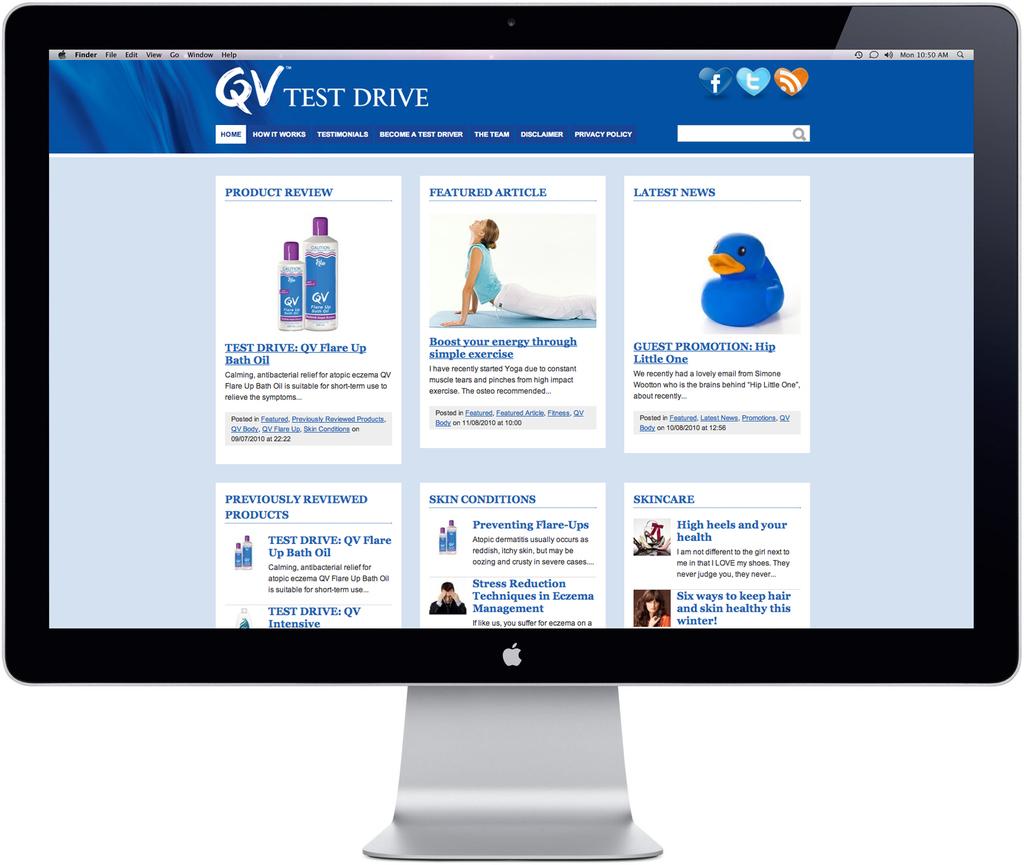What social media platforms are advertised?
Keep it short and to the point. Facebook twitter. What website is this?
Make the answer very short. Qv test drive. 